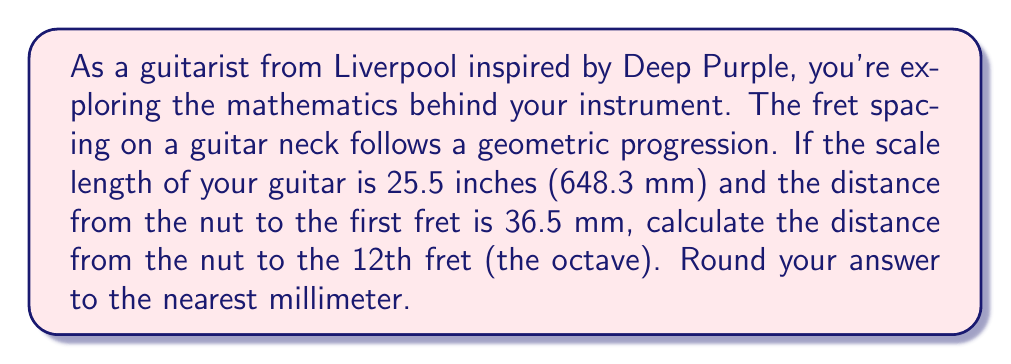Can you solve this math problem? To solve this problem, we need to understand the geometric progression of fret spacing on a guitar neck:

1) The fret positions follow a geometric sequence with a common ratio of $\sqrt[12]{2}$ (the twelfth root of 2). This ratio ensures that each fret represents a semitone in the 12-tone equal temperament system.

2) Let's define the scale length as $L$ and the distance from the nut to the nth fret as $d_n$. The formula for the distance from the nut to the nth fret is:

   $$d_n = L(1 - (\frac{1}{\sqrt[12]{2}})^n)$$

3) We're given that $L = 648.3$ mm and $d_1 = 36.5$ mm. We can verify this using the formula:

   $$36.5 \approx 648.3(1 - (\frac{1}{\sqrt[12]{2}})^1)$$

4) To find the distance to the 12th fret, we use $n = 12$ in our formula:

   $$d_{12} = 648.3(1 - (\frac{1}{\sqrt[12]{2}})^{12})$$

5) Simplify:
   $$d_{12} = 648.3(1 - \frac{1}{2}) = 648.3 \cdot 0.5 = 324.15$$

6) Rounding to the nearest millimeter:
   $$d_{12} \approx 324 \text{ mm}$$

This result aligns with the fact that the 12th fret (the octave) is typically located at exactly half the scale length of the guitar.
Answer: 324 mm 